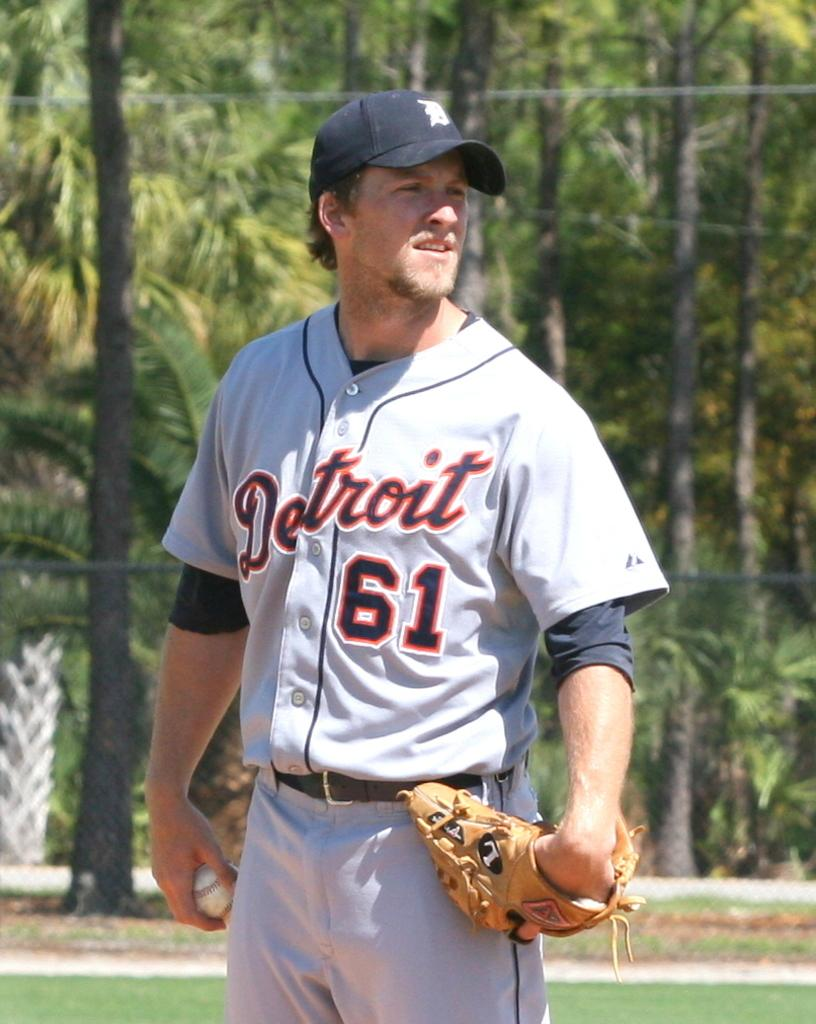What is the main subject of the image? There is a man in the image. What is the man doing in the image? The man is standing and looking at someone. What objects does the man have in his hands? The man has a ball and a glove in his hands. What type of headwear is the man wearing? The man is wearing a cap. What can be seen in the background of the image? There are trees visible in the background of the image. What type of food is the man eating in the image? There is no food present in the image; the man has a ball and a glove in his hands. What type of music is the man playing in the image? There is no music or musical instrument present in the image; the man has a ball and a glove in his hands. 